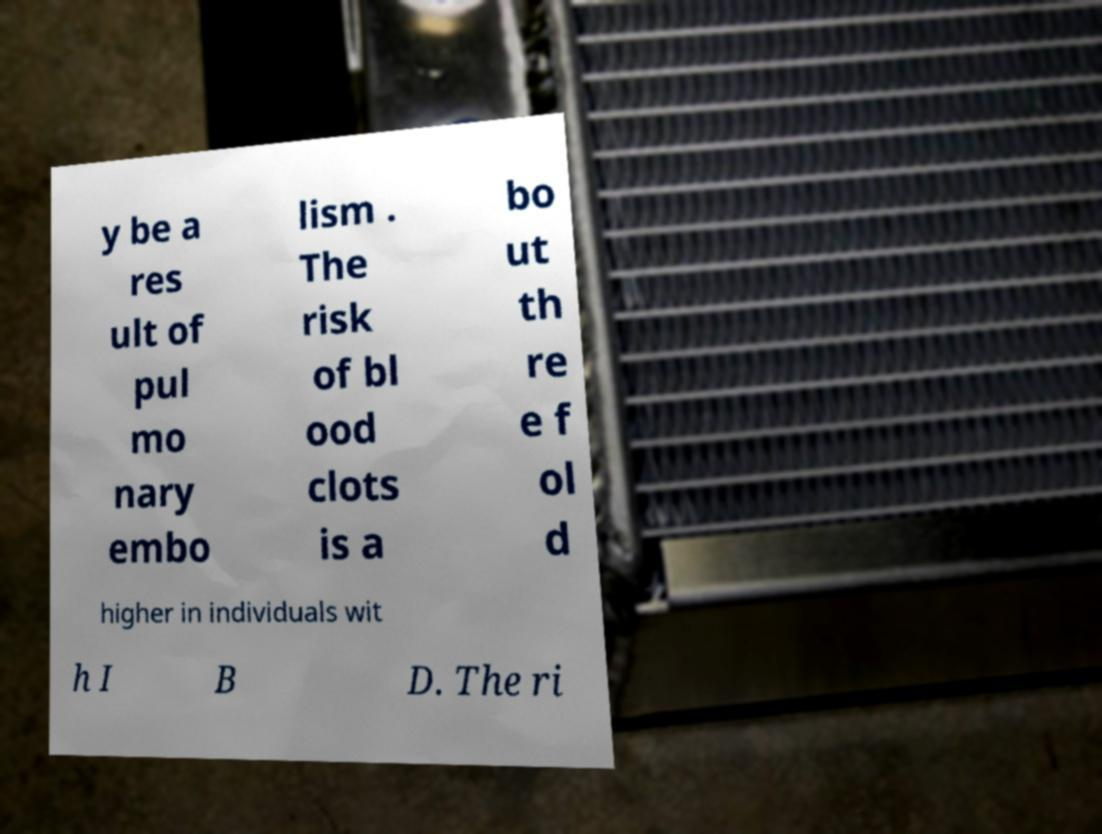Please read and relay the text visible in this image. What does it say? y be a res ult of pul mo nary embo lism . The risk of bl ood clots is a bo ut th re e f ol d higher in individuals wit h I B D. The ri 